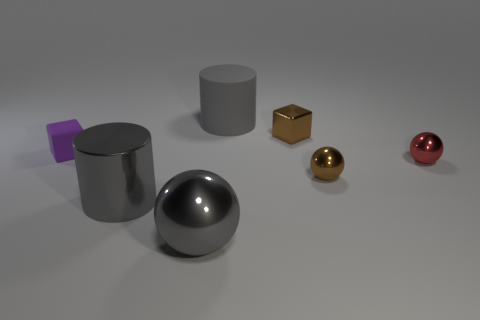There is a rubber object that is the same size as the gray metal cylinder; what is its shape?
Your answer should be compact. Cylinder. What number of red things are small cubes or cylinders?
Offer a very short reply. 0. How many metal cylinders are the same size as the gray ball?
Make the answer very short. 1. What is the shape of the object that is the same color as the metal block?
Your response must be concise. Sphere. How many things are brown spheres or small things that are in front of the red ball?
Make the answer very short. 1. Does the gray cylinder behind the big gray metallic cylinder have the same size as the cylinder that is on the left side of the large gray matte cylinder?
Make the answer very short. Yes. What number of other big objects are the same shape as the gray matte object?
Give a very brief answer. 1. There is a red object that is made of the same material as the brown ball; what is its shape?
Offer a terse response. Sphere. The cube right of the gray cylinder that is behind the matte thing that is in front of the tiny brown shiny block is made of what material?
Offer a terse response. Metal. Is the size of the gray metal cylinder the same as the metallic object that is on the right side of the brown sphere?
Your answer should be very brief. No. 